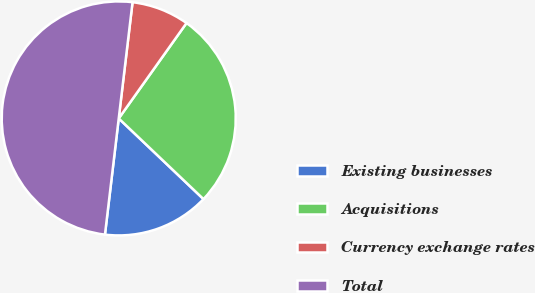<chart> <loc_0><loc_0><loc_500><loc_500><pie_chart><fcel>Existing businesses<fcel>Acquisitions<fcel>Currency exchange rates<fcel>Total<nl><fcel>14.77%<fcel>27.27%<fcel>7.95%<fcel>50.0%<nl></chart> 